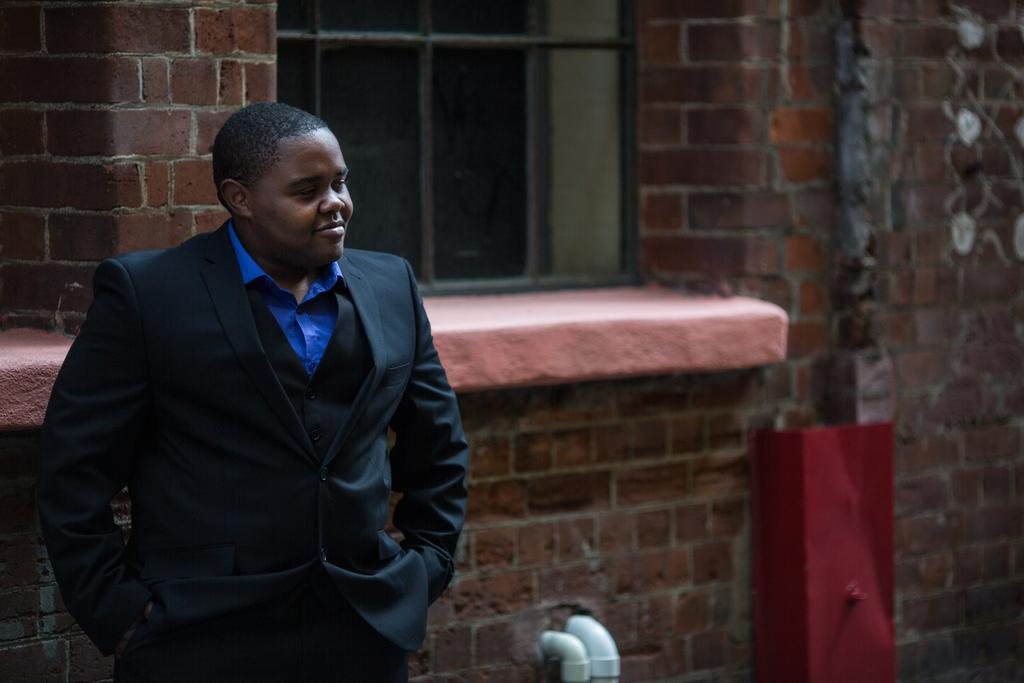What can be seen in the image? There is a person in the image. How is the person's expression? The person is smiling. What type of building is visible in the image? There is a building with red bricks in the image. Can you see any cows in the image? There are no cows present in the image. What type of ground is the person standing on in the image? The provided facts do not mention the ground or any details about the surface the person is standing on. 